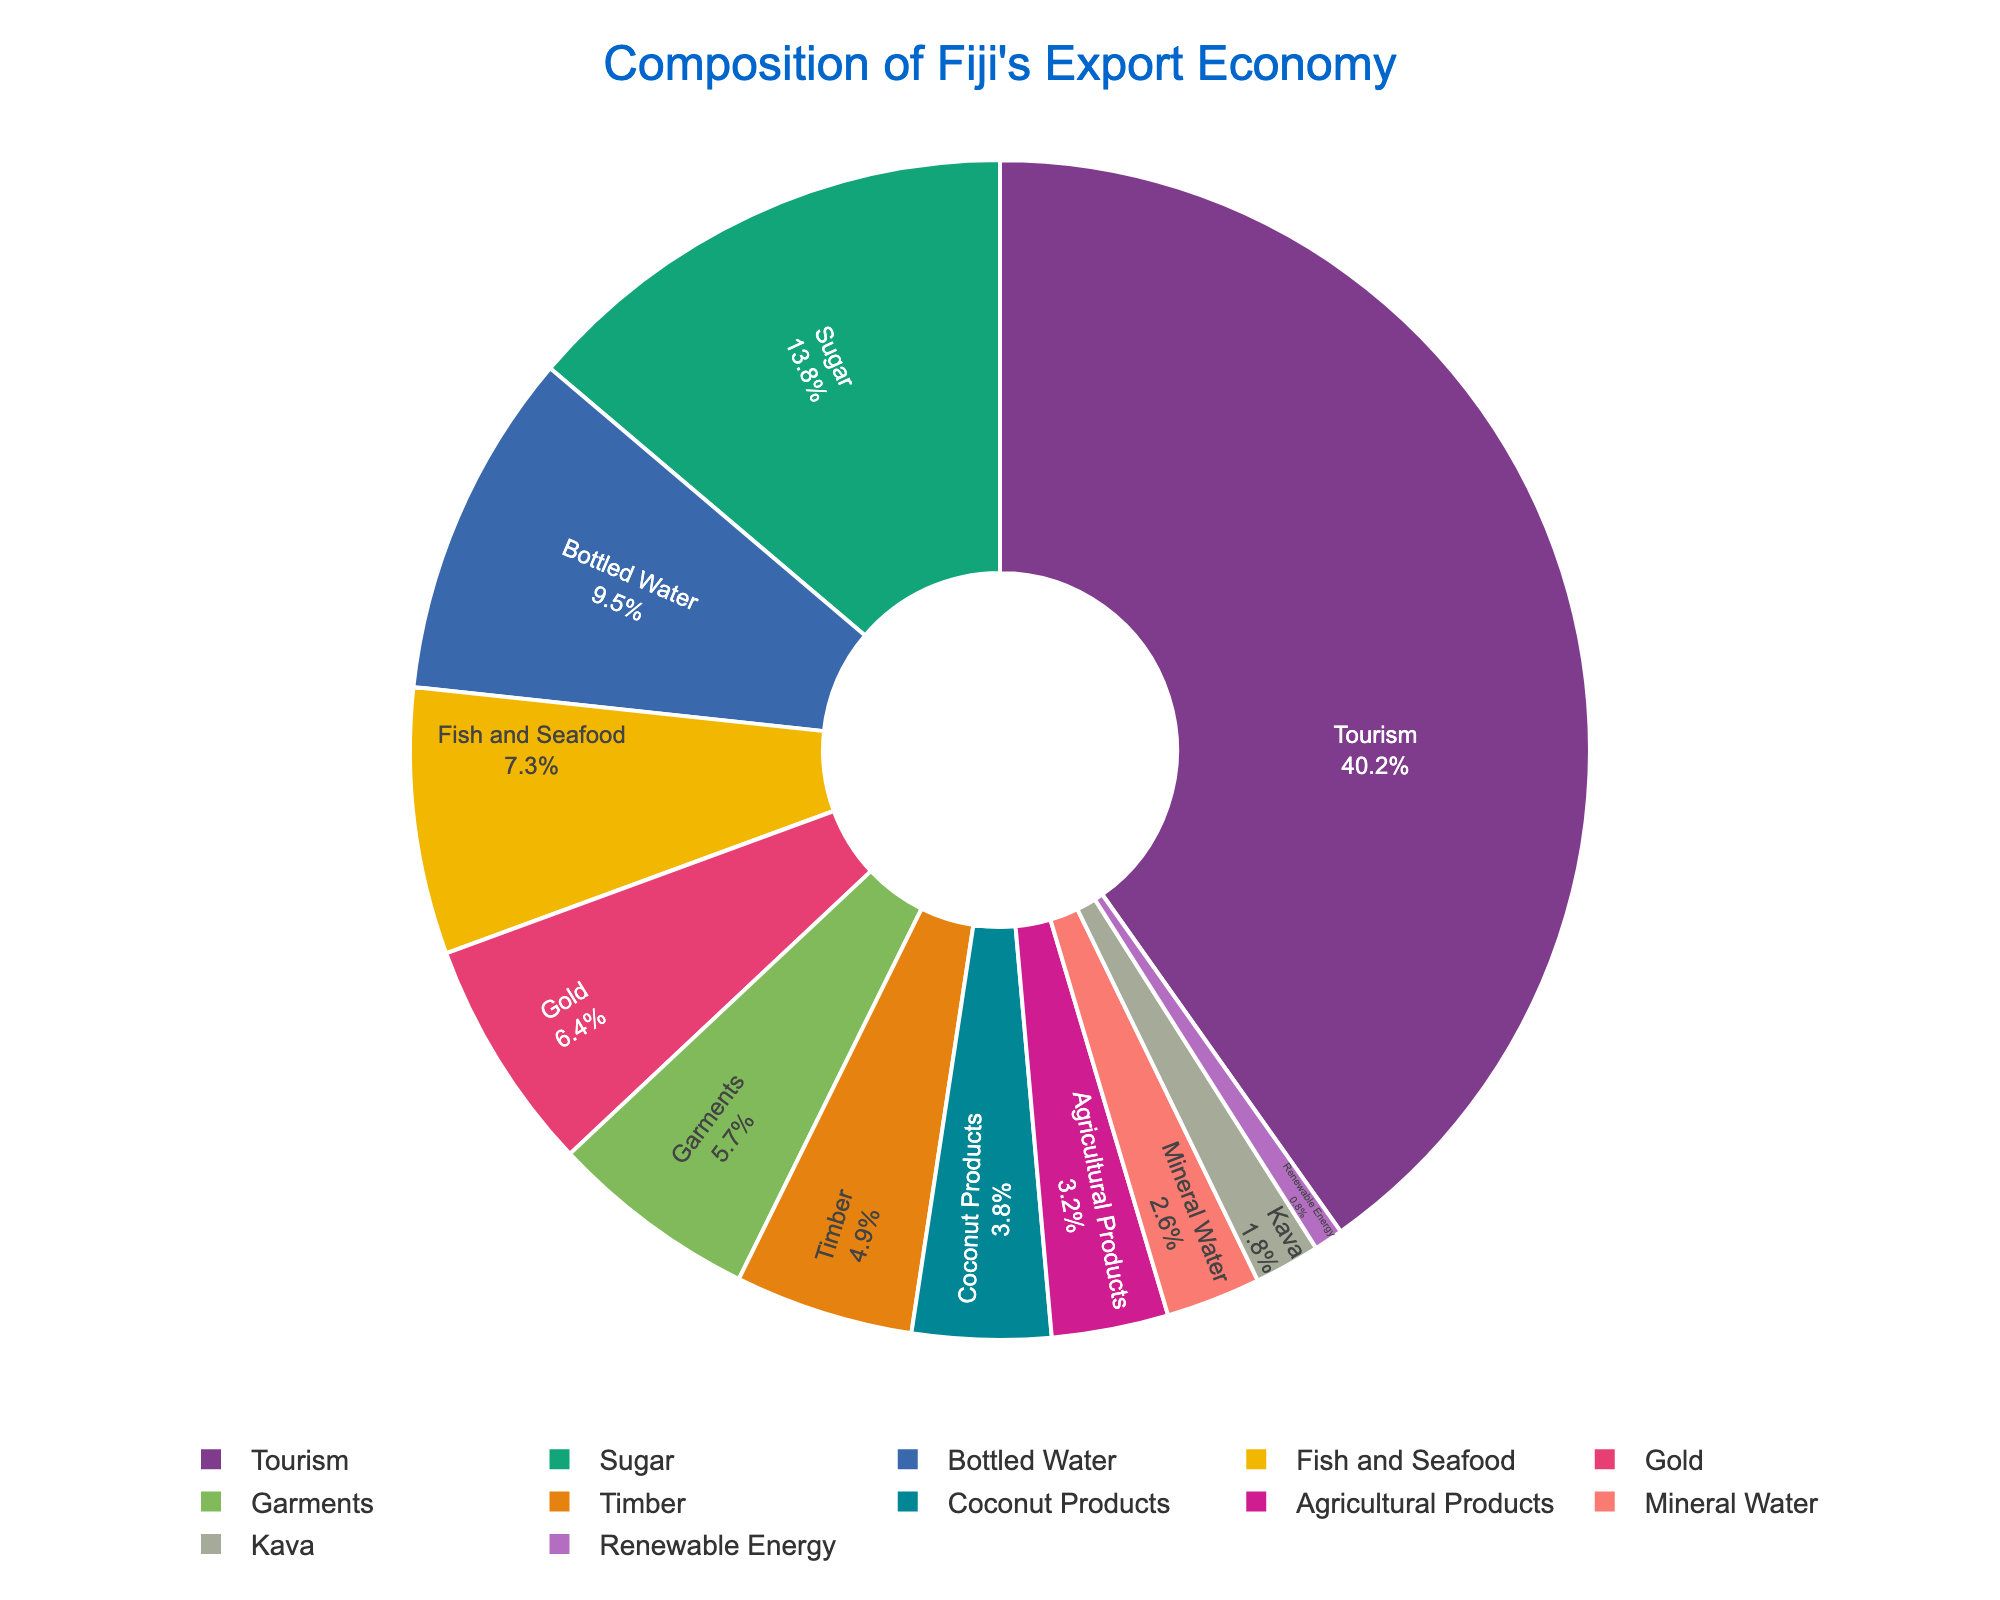What's the sum of the percentages for the top three industries? The top three industries by percentage are Tourism (40.2%), Sugar (13.8%), and Bottled Water (9.5%). Adding these together: 40.2 + 13.8 + 9.5 = 63.5%.
Answer: 63.5% Which industry has a higher percentage: Fish and Seafood or Gold? The percentage for Fish and Seafood is 7.3% and for Gold is 6.4%. Comparing the two, Fish and Seafood has a higher percentage.
Answer: Fish and Seafood By how much does the percentage of Tourism exceed the combined percentages of Kava and Renewable Energy? The percentage of Tourism is 40.2%. The combined percentages of Kava (1.8%) and Renewable Energy (0.8%) are 1.8 + 0.8 = 2.6%. The difference is 40.2 - 2.6 = 37.6%.
Answer: 37.6% What is the median percentage value of all the listed industries? The percentages in ascending order are: 0.8, 1.8, 2.6, 3.2, 3.8, 4.9, 5.7, 6.4, 7.3, 9.5, 13.8, 40.2. Since there are 12 values, the median is the average of the 6th and 7th values: (4.9 + 5.7) / 2 = 5.3%.
Answer: 5.3% Which industry has the smallest percentage? The industry with the smallest percentage is Renewable Energy, with a percentage of 0.8%.
Answer: Renewable Energy If Bottled Water and Mineral Water were combined into one category, what would be their total percentage? Bottled Water has 9.5% and Mineral Water has 2.6%. Their combined percentage would be 9.5 + 2.6 = 12.1%.
Answer: 12.1% Is the percentage of Timber more than double that of Kava? The percentage of Timber is 4.9% and Kava is 1.8%. Double the percentage of Kava is 1.8 * 2 = 3.6%. Since 4.9% is greater than 3.6%, the percentage of Timber is more than double that of Kava.
Answer: Yes Which industries have percentages between 5% and 10%? The industries with percentages between 5% and 10% are Bottled Water (9.5%), Fish and Seafood (7.3%), Gold (6.4%), and Garments (5.7%).
Answer: Bottled Water, Fish and Seafood, Gold, Garments What's the total percentage of all the industries listed? The sum of all the percentages provided is 40.2 + 13.8 + 9.5 + 7.3 + 6.4 + 5.7 + 4.9 + 3.8 + 3.2 + 2.6 + 1.8 + 0.8 = 100%.
Answer: 100% How much higher is the percentage of Sugar compared to Garments? The percentage of Sugar is 13.8% and Garments is 5.7%. The difference is 13.8 - 5.7 = 8.1%.
Answer: 8.1% 